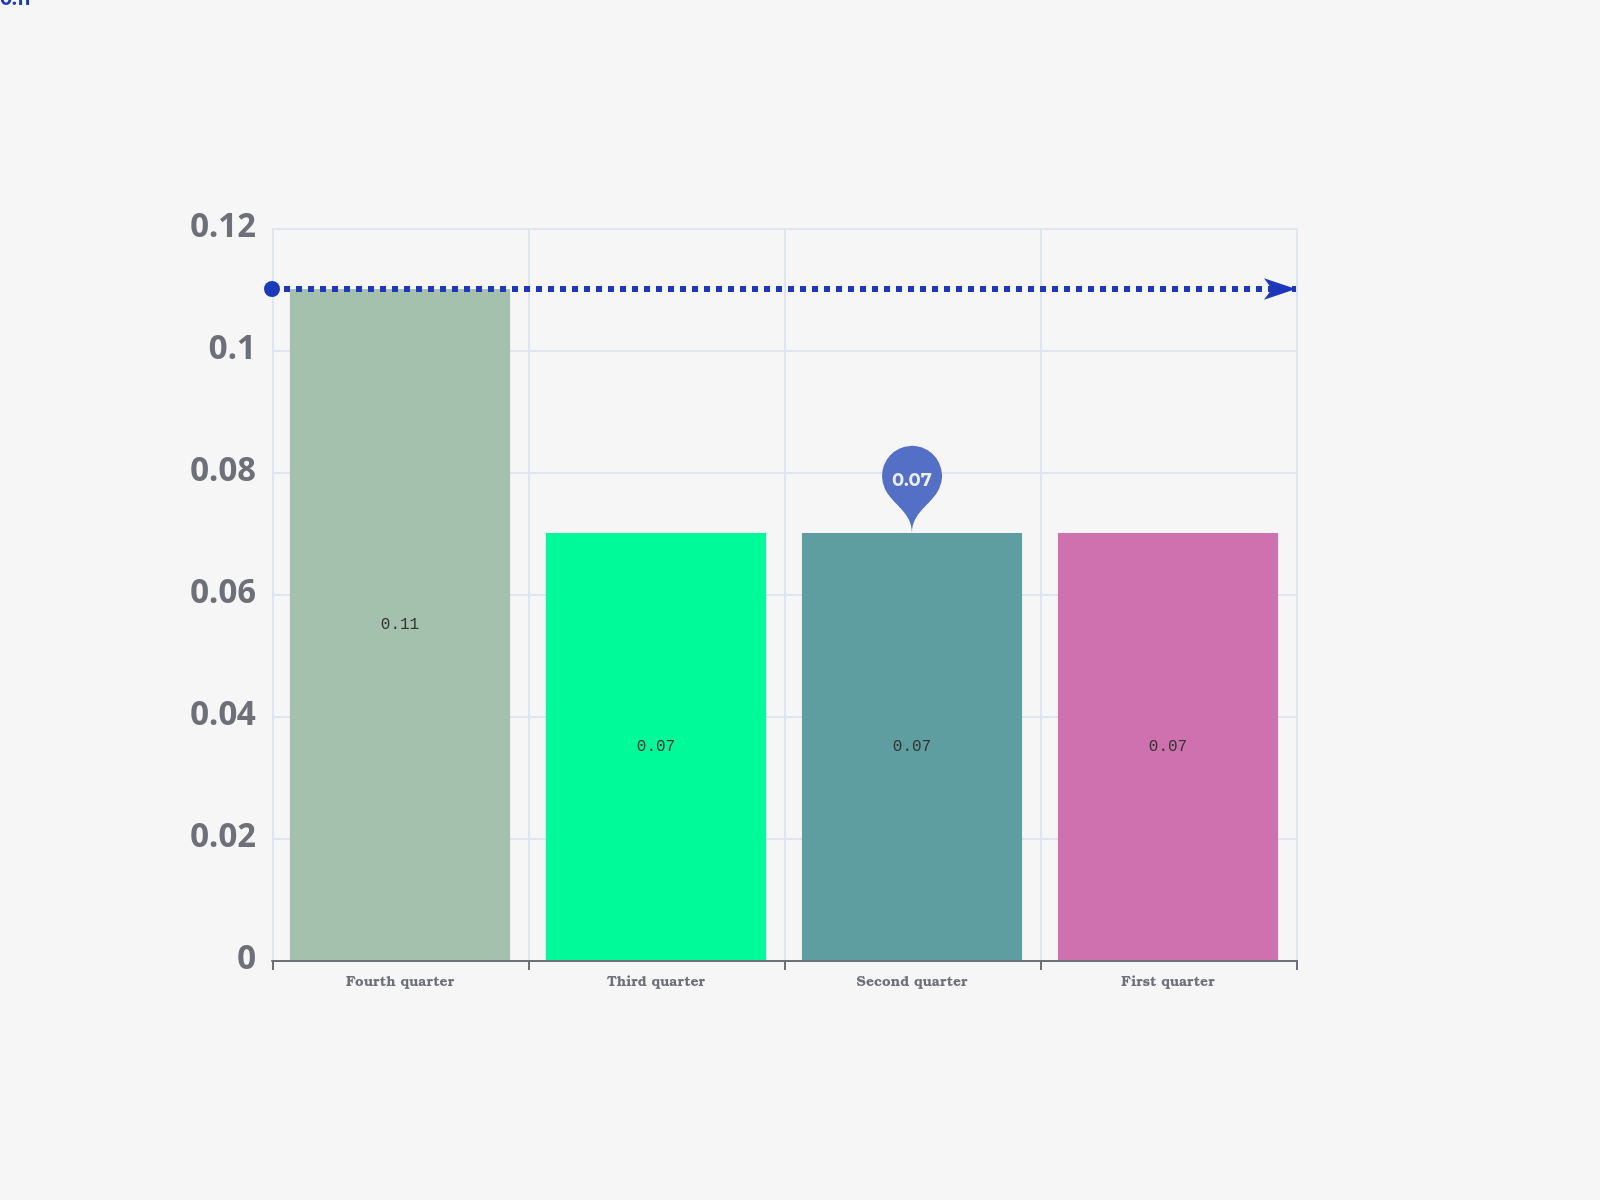Convert chart to OTSL. <chart><loc_0><loc_0><loc_500><loc_500><bar_chart><fcel>Fourth quarter<fcel>Third quarter<fcel>Second quarter<fcel>First quarter<nl><fcel>0.11<fcel>0.07<fcel>0.07<fcel>0.07<nl></chart> 